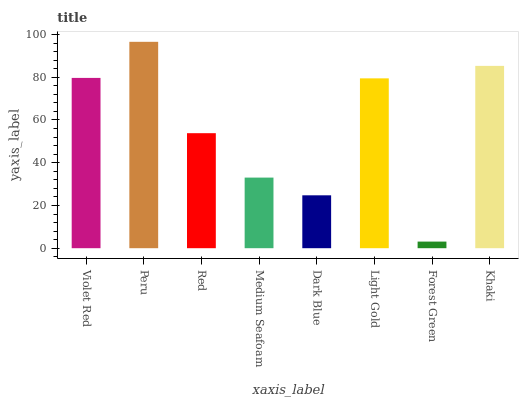Is Red the minimum?
Answer yes or no. No. Is Red the maximum?
Answer yes or no. No. Is Peru greater than Red?
Answer yes or no. Yes. Is Red less than Peru?
Answer yes or no. Yes. Is Red greater than Peru?
Answer yes or no. No. Is Peru less than Red?
Answer yes or no. No. Is Light Gold the high median?
Answer yes or no. Yes. Is Red the low median?
Answer yes or no. Yes. Is Khaki the high median?
Answer yes or no. No. Is Medium Seafoam the low median?
Answer yes or no. No. 